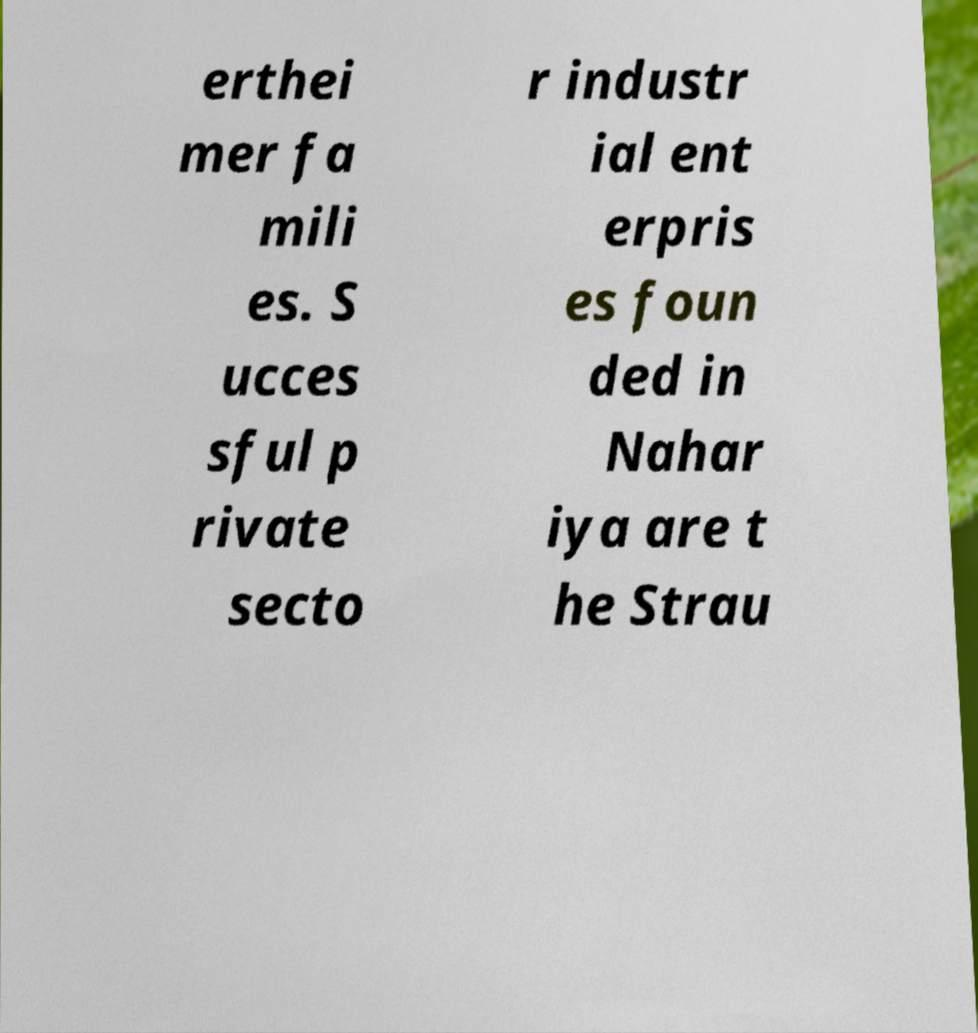Could you extract and type out the text from this image? erthei mer fa mili es. S ucces sful p rivate secto r industr ial ent erpris es foun ded in Nahar iya are t he Strau 